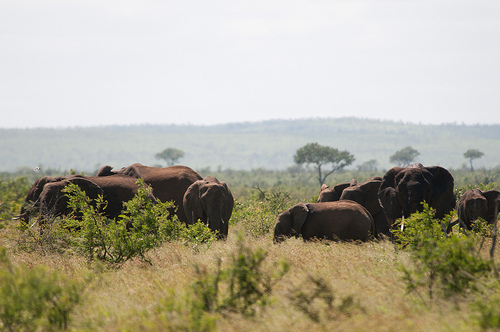Describe the climate conditions suggested by the vegetation. The vegetation indicates a semi-arid climate, typical of the savannah, with sparse trees and dry grass dominating the landscape, suggestive of low rainfall and high evaporation. 